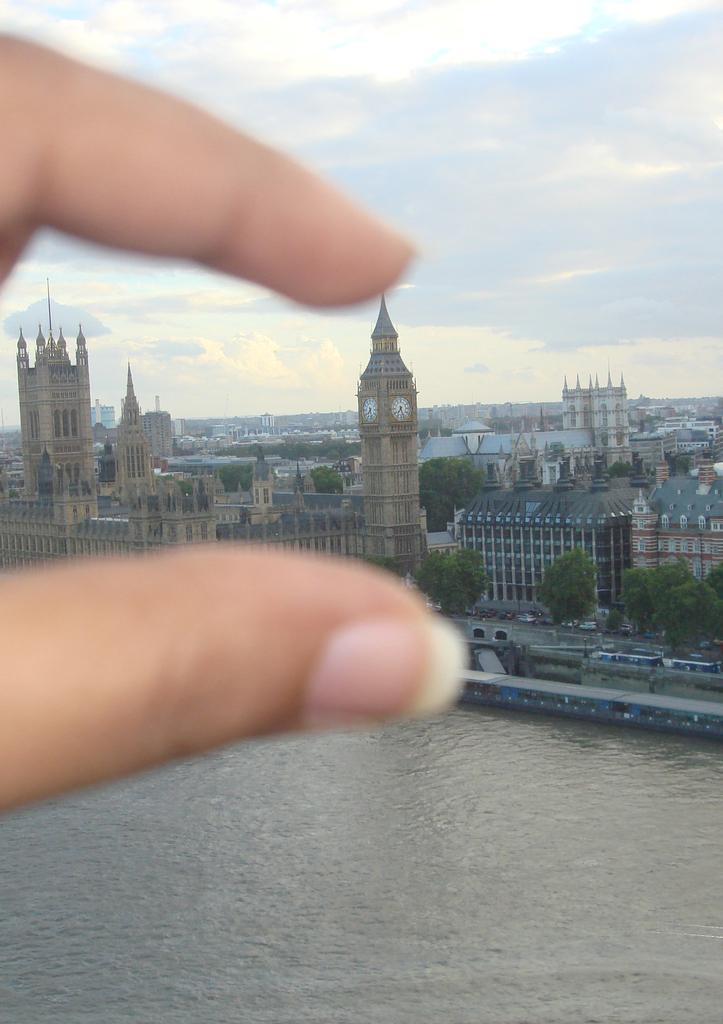In one or two sentences, can you explain what this image depicts? In this picture we can see a person´s fingers in the front, at the bottom there is water, in the background we can see trees, vehicles, buildings, a clock tower. We can see the sky at the top of the picture. 